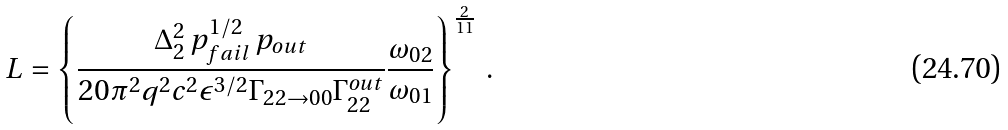<formula> <loc_0><loc_0><loc_500><loc_500>L = \left \{ \frac { \Delta _ { 2 } ^ { 2 } \, p _ { f a i l } ^ { 1 / 2 } \, p _ { o u t } } { 2 0 \pi ^ { 2 } q ^ { 2 } c ^ { 2 } \epsilon ^ { 3 / 2 } \Gamma _ { 2 2 \rightarrow 0 0 } \Gamma _ { 2 2 } ^ { o u t } } \frac { \omega _ { 0 2 } } { \omega _ { 0 1 } } \right \} ^ { \frac { 2 } { 1 1 } } \, .</formula> 